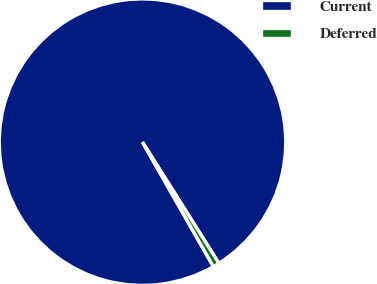Convert chart to OTSL. <chart><loc_0><loc_0><loc_500><loc_500><pie_chart><fcel>Current<fcel>Deferred<nl><fcel>99.28%<fcel>0.72%<nl></chart> 